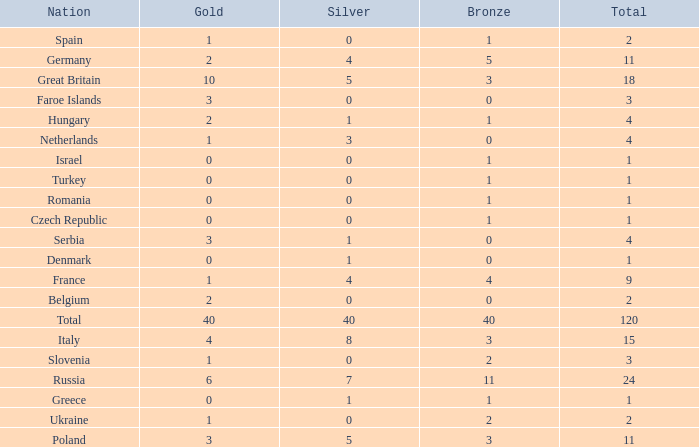What is Turkey's average Gold entry that also has a Bronze entry that is smaller than 2 and the Total is greater than 1? None. 